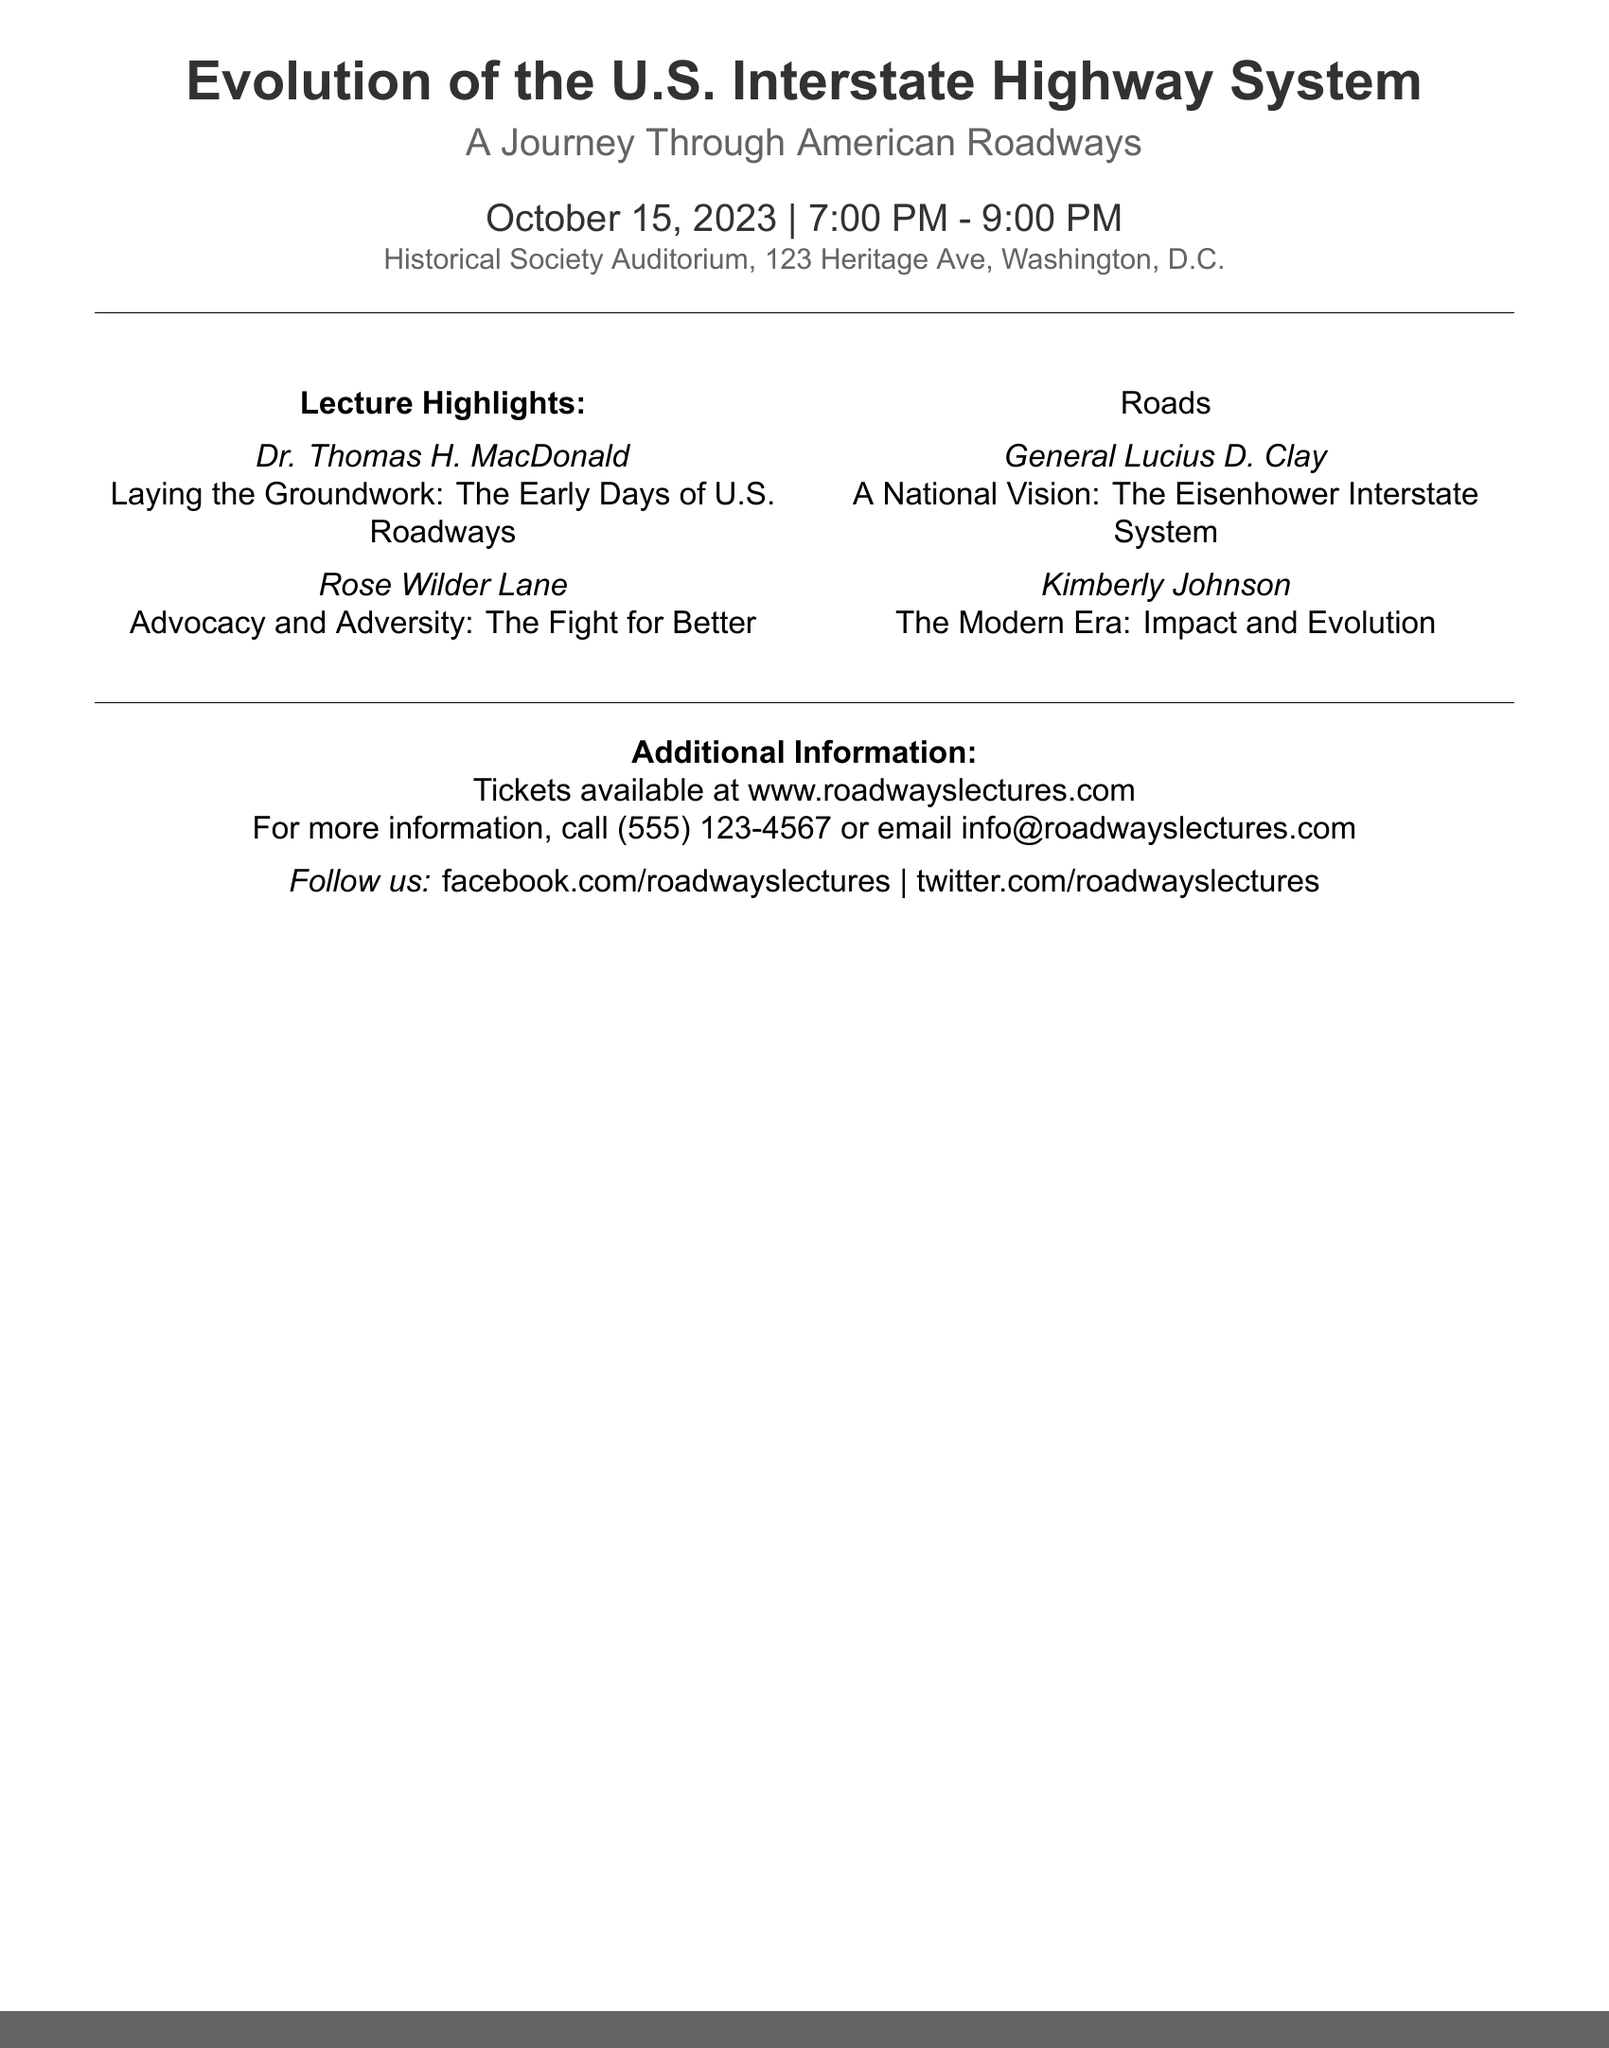What is the date of the lecture? The date of the lecture is mentioned in the document as October 15, 2023.
Answer: October 15, 2023 What time does the lecture start? The starting time of the lecture can be found in the document, which states 7:00 PM.
Answer: 7:00 PM Who is speaking about the early days of U.S. roadways? The document lists Dr. Thomas H. MacDonald as the speaker discussing early days of U.S. roadways.
Answer: Dr. Thomas H. MacDonald What location is the lecture being held at? The document includes the venue information, which is the Historical Society Auditorium, 123 Heritage Ave, Washington, D.C.
Answer: Historical Society Auditorium, 123 Heritage Ave, Washington, D.C What major topic does General Lucius D. Clay discuss? The document indicates that General Lucius D. Clay will talk about the Eisenhower Interstate System, a significant development in U.S. roadways.
Answer: The Eisenhower Interstate System How many speakers are featured in the lecture? The document lists four different speakers involved in the lecture topics.
Answer: Four What is the primary subject of the lecture? The main focus of the lecture is indicated in the title, which is the evolution of the U.S. Interstate Highway System.
Answer: Evolution of the U.S. Interstate Highway System What is the ticket purchase website? The document provides the URL for ticket purchases, which is www.roadwayslectures.com.
Answer: www.roadwayslectures.com What color is used for the headings in the document? The document consistently uses the color asphalt for headings, as indicated in the format.
Answer: Asphalt 